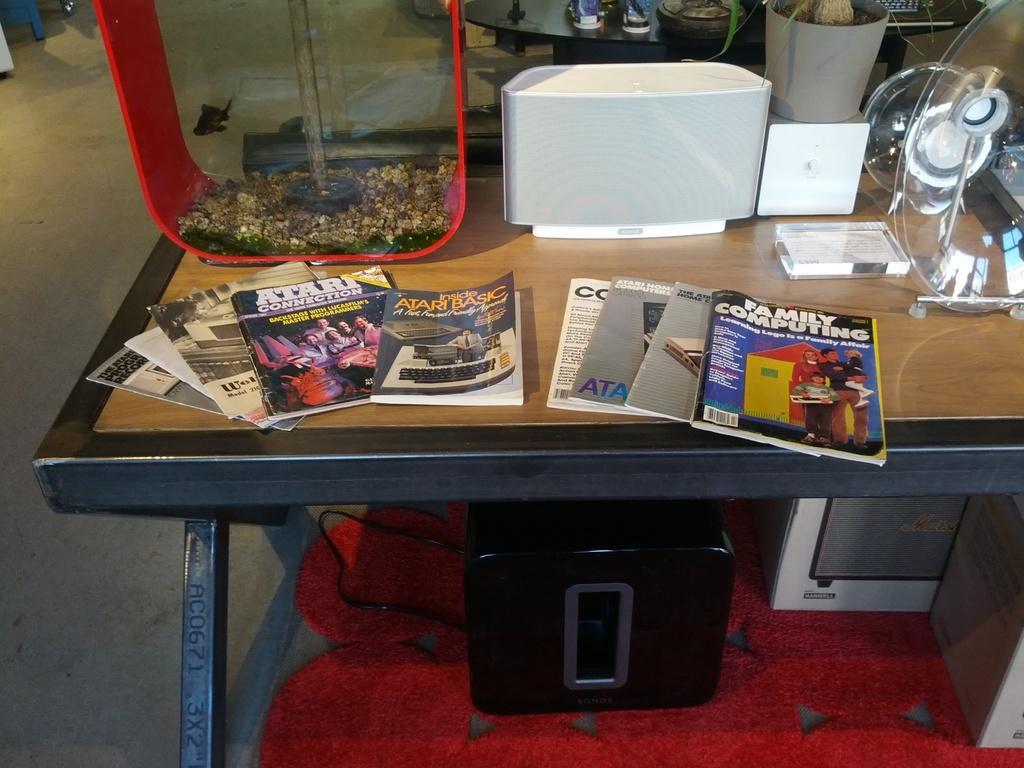Please provide a concise description of this image. This picture is taken inside the room. In this image, we can see a table, on that table, we can see some books and some glass instrument, few boxes, under the table, we can also see a black color electronic box and a red color mat. On the left side, we can see a land. In the background, we can also see another table. 